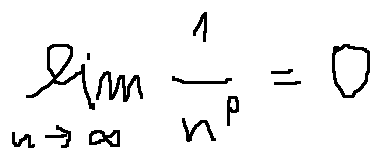<formula> <loc_0><loc_0><loc_500><loc_500>\lim \lim i t s _ { n \rightarrow \infty } \frac { 1 } { n ^ { p } } = 0</formula> 